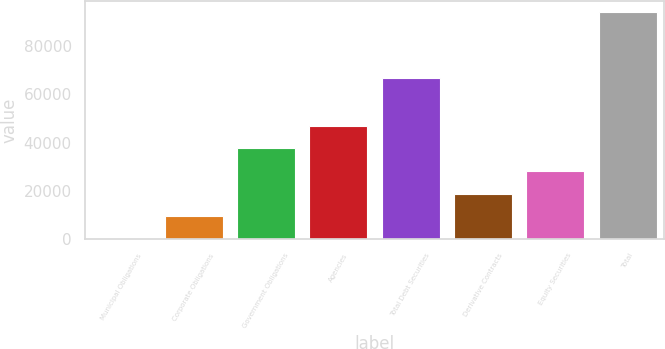<chart> <loc_0><loc_0><loc_500><loc_500><bar_chart><fcel>Municipal Obligations<fcel>Corporate Obligations<fcel>Government Obligations<fcel>Agencies<fcel>Total Debt Securities<fcel>Derivative Contracts<fcel>Equity Securities<fcel>Total<nl><fcel>5<fcel>9405.4<fcel>37606.6<fcel>47007<fcel>66632<fcel>18805.8<fcel>28206.2<fcel>94009<nl></chart> 